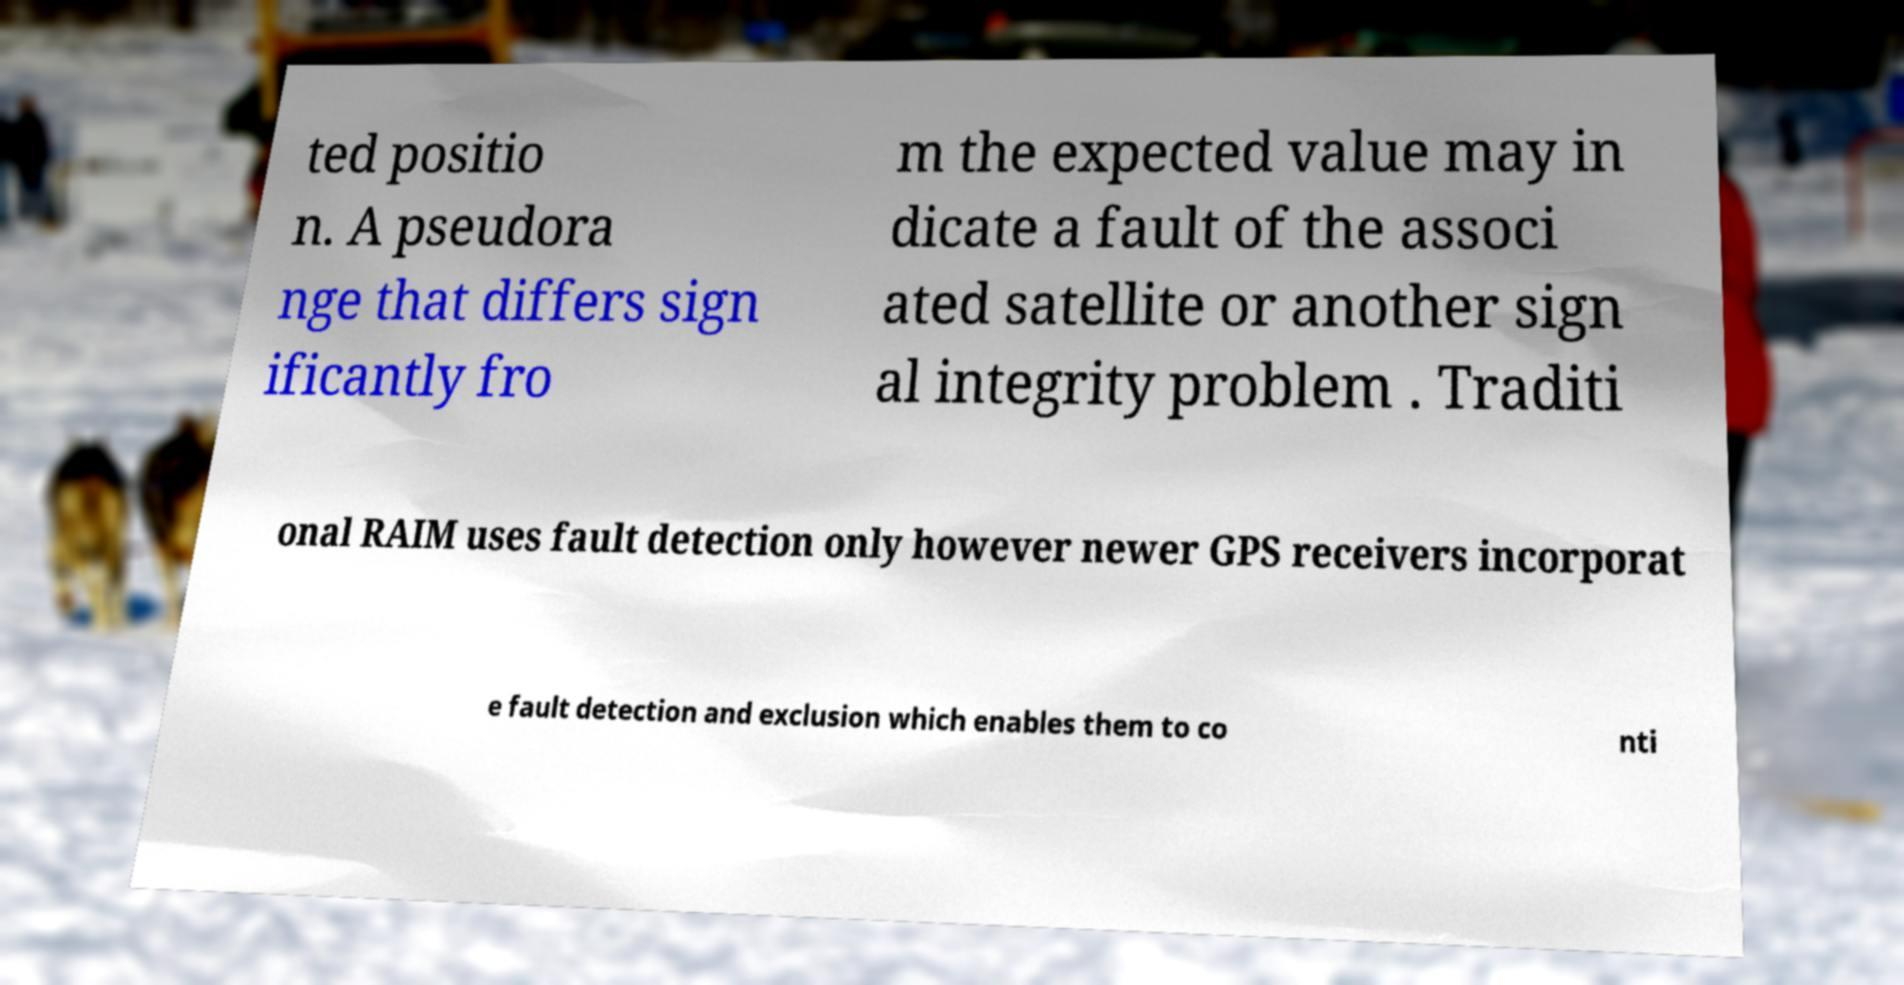Can you read and provide the text displayed in the image?This photo seems to have some interesting text. Can you extract and type it out for me? ted positio n. A pseudora nge that differs sign ificantly fro m the expected value may in dicate a fault of the associ ated satellite or another sign al integrity problem . Traditi onal RAIM uses fault detection only however newer GPS receivers incorporat e fault detection and exclusion which enables them to co nti 